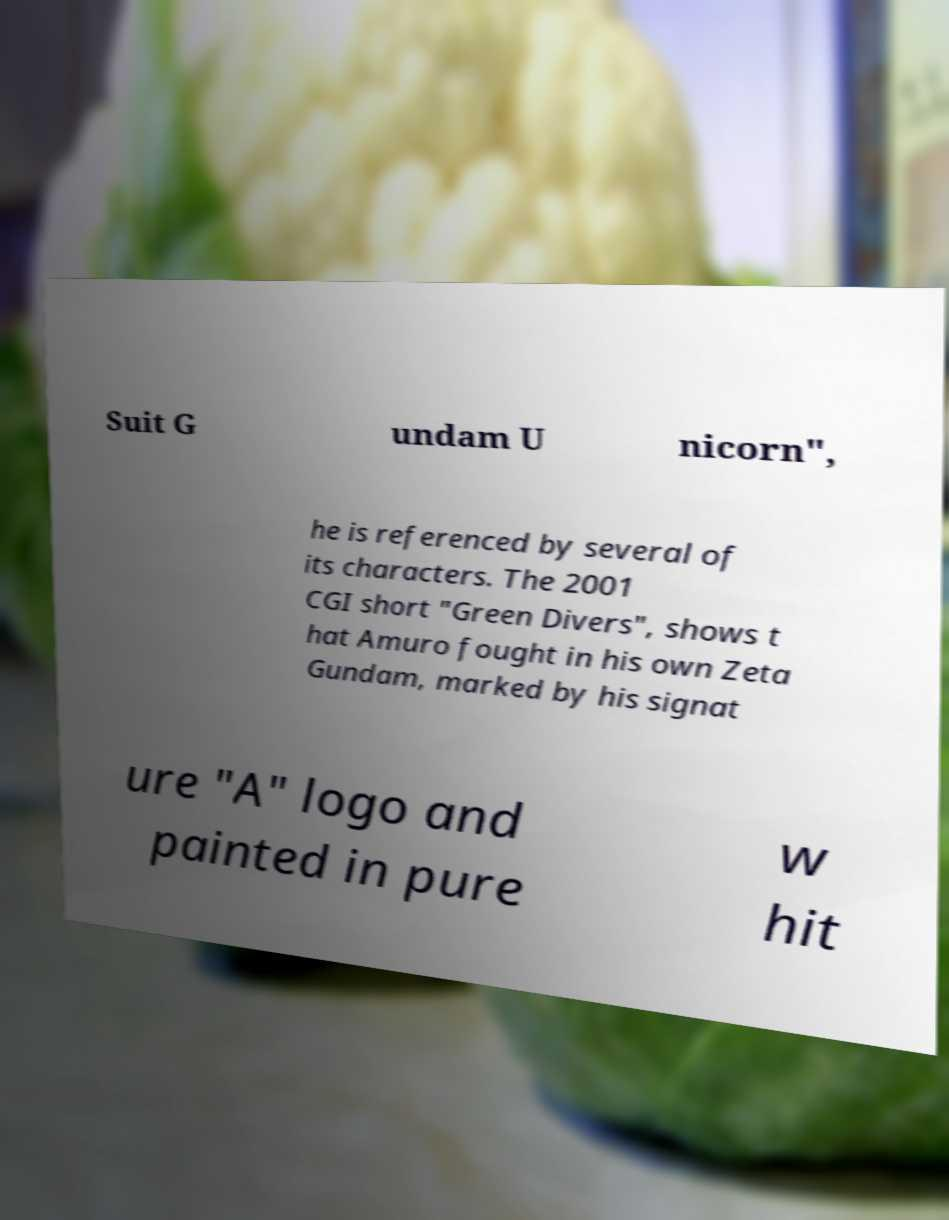Could you extract and type out the text from this image? Suit G undam U nicorn", he is referenced by several of its characters. The 2001 CGI short "Green Divers", shows t hat Amuro fought in his own Zeta Gundam, marked by his signat ure "A" logo and painted in pure w hit 